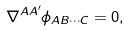<formula> <loc_0><loc_0><loc_500><loc_500>\nabla ^ { A A ^ { \prime } } \phi _ { A B \cdots C } = 0 ,</formula> 